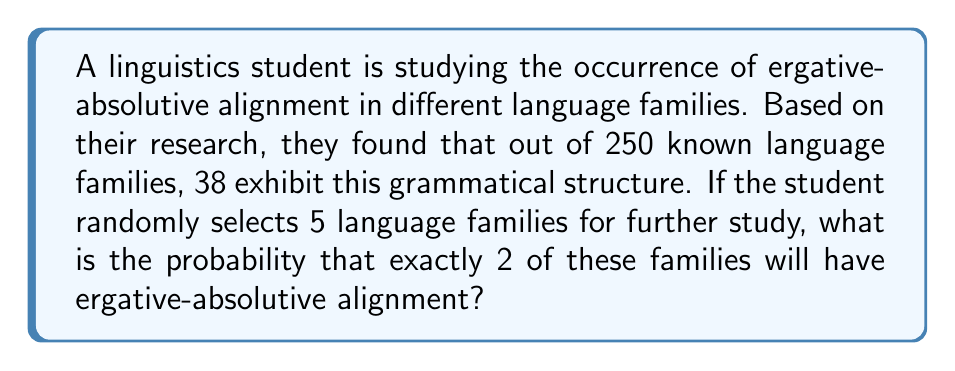Could you help me with this problem? To solve this problem, we can use the binomial probability formula. Let's break it down step by step:

1. Define our variables:
   $n$ = number of trials (selected language families) = 5
   $k$ = number of successes (families with ergative-absolutive alignment) = 2
   $p$ = probability of success on a single trial = 38/250 = 0.152

2. The binomial probability formula is:

   $$P(X = k) = \binom{n}{k} p^k (1-p)^{n-k}$$

3. Calculate the binomial coefficient:
   $$\binom{5}{2} = \frac{5!}{2!(5-2)!} = \frac{5 \cdot 4}{2 \cdot 1} = 10$$

4. Substitute the values into the formula:

   $$P(X = 2) = 10 \cdot (0.152)^2 \cdot (1-0.152)^{5-2}$$

5. Simplify:
   $$P(X = 2) = 10 \cdot (0.152)^2 \cdot (0.848)^3$$

6. Calculate:
   $$P(X = 2) = 10 \cdot 0.023104 \cdot 0.609774 = 0.1409$$

Therefore, the probability of selecting exactly 2 language families with ergative-absolutive alignment out of 5 randomly chosen families is approximately 0.1409 or 14.09%.
Answer: 0.1409 or 14.09% 